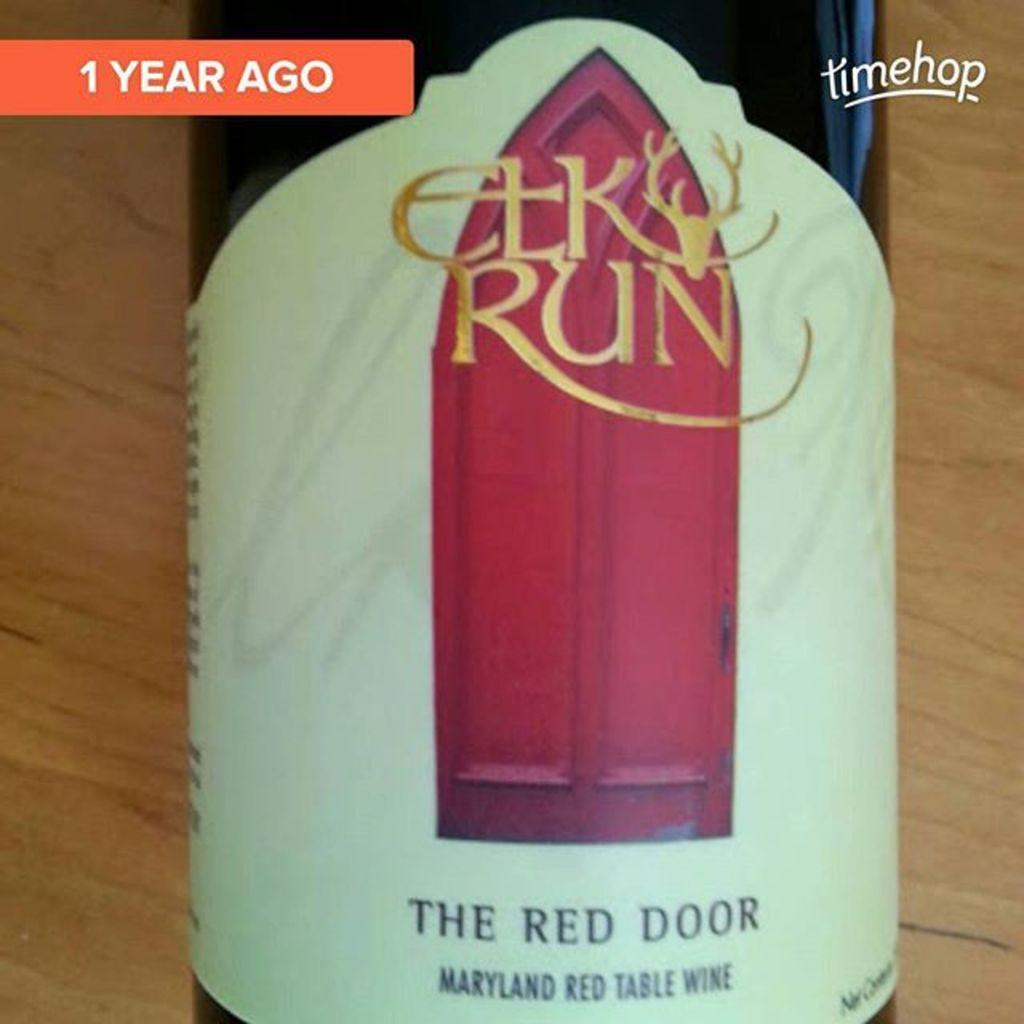<image>
Render a clear and concise summary of the photo. The label of a Maryland red table wine called "The Red Door". 